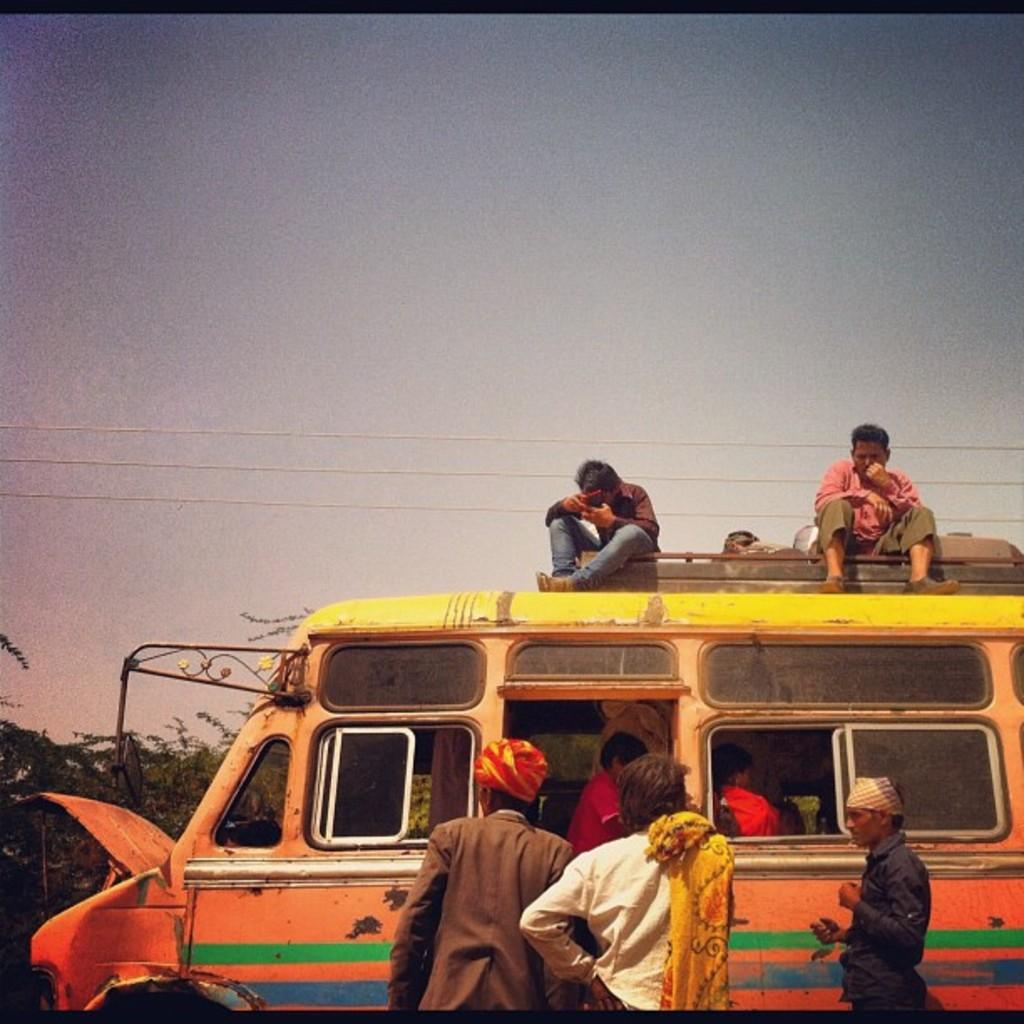What is the main subject in the image? There is a vehicle in the image. What can be seen in the background of the image? There are trees and wires in the image. What is visible in the sky in the image? The sky is visible in the image. What are the people in the image doing? Some people are sitting, and some are standing in the image. What type of plantation can be seen in the image? There is no plantation present in the image. What is the friction between the vehicle and the ground in the image? The image does not provide information about the friction between the vehicle and the ground. 